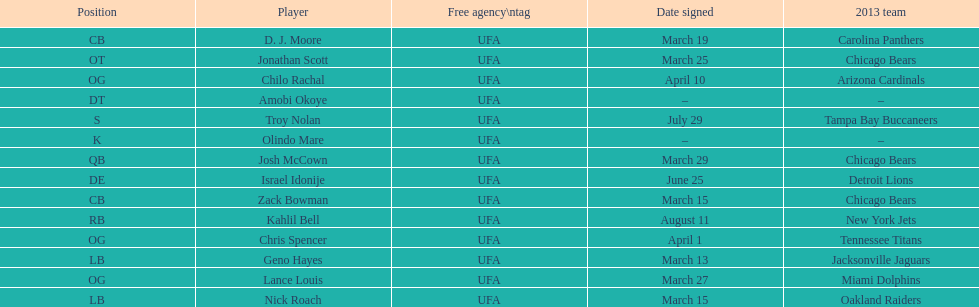Signed the same date as "april fools day". Chris Spencer. 